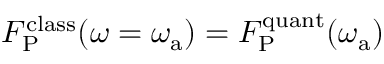Convert formula to latex. <formula><loc_0><loc_0><loc_500><loc_500>F _ { P } ^ { c l a s s } ( \omega = \omega _ { a } ) = F _ { P } ^ { q u a n t } ( \omega _ { a } )</formula> 